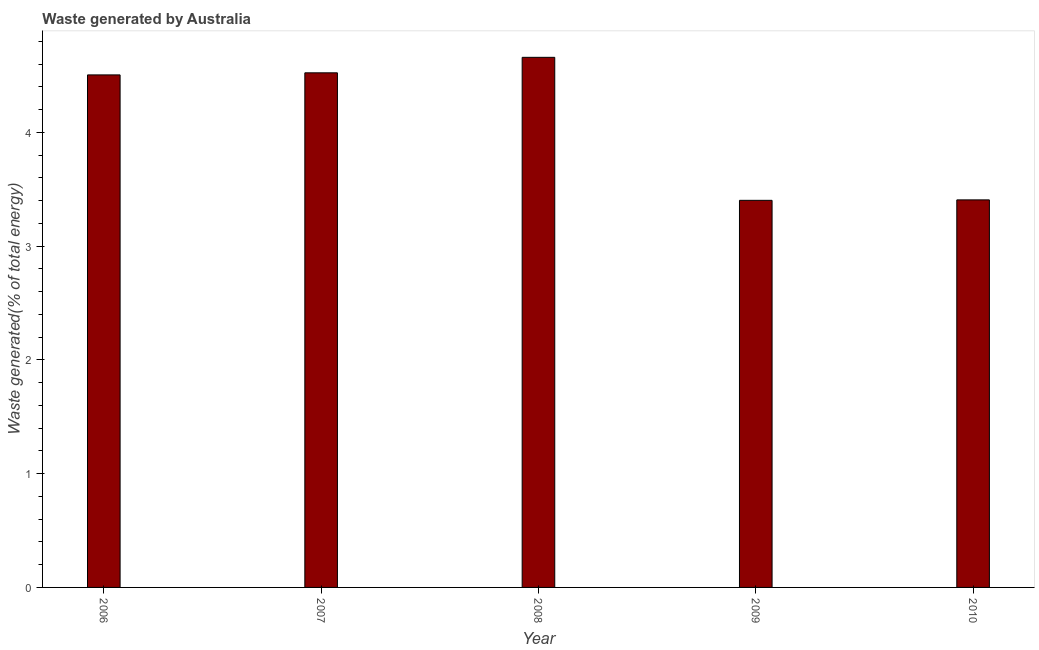Does the graph contain grids?
Give a very brief answer. No. What is the title of the graph?
Your response must be concise. Waste generated by Australia. What is the label or title of the X-axis?
Ensure brevity in your answer.  Year. What is the label or title of the Y-axis?
Keep it short and to the point. Waste generated(% of total energy). What is the amount of waste generated in 2008?
Give a very brief answer. 4.66. Across all years, what is the maximum amount of waste generated?
Ensure brevity in your answer.  4.66. Across all years, what is the minimum amount of waste generated?
Your response must be concise. 3.4. In which year was the amount of waste generated maximum?
Provide a succinct answer. 2008. In which year was the amount of waste generated minimum?
Provide a short and direct response. 2009. What is the sum of the amount of waste generated?
Your answer should be very brief. 20.5. What is the difference between the amount of waste generated in 2008 and 2010?
Your answer should be compact. 1.25. What is the average amount of waste generated per year?
Offer a very short reply. 4.1. What is the median amount of waste generated?
Ensure brevity in your answer.  4.51. Is the amount of waste generated in 2008 less than that in 2009?
Your answer should be compact. No. Is the difference between the amount of waste generated in 2006 and 2007 greater than the difference between any two years?
Keep it short and to the point. No. What is the difference between the highest and the second highest amount of waste generated?
Your answer should be very brief. 0.14. What is the difference between the highest and the lowest amount of waste generated?
Offer a very short reply. 1.26. In how many years, is the amount of waste generated greater than the average amount of waste generated taken over all years?
Your response must be concise. 3. Are all the bars in the graph horizontal?
Ensure brevity in your answer.  No. How many years are there in the graph?
Offer a terse response. 5. What is the difference between two consecutive major ticks on the Y-axis?
Provide a succinct answer. 1. Are the values on the major ticks of Y-axis written in scientific E-notation?
Offer a terse response. No. What is the Waste generated(% of total energy) in 2006?
Your answer should be very brief. 4.51. What is the Waste generated(% of total energy) of 2007?
Make the answer very short. 4.52. What is the Waste generated(% of total energy) in 2008?
Provide a short and direct response. 4.66. What is the Waste generated(% of total energy) in 2009?
Provide a succinct answer. 3.4. What is the Waste generated(% of total energy) in 2010?
Keep it short and to the point. 3.41. What is the difference between the Waste generated(% of total energy) in 2006 and 2007?
Ensure brevity in your answer.  -0.02. What is the difference between the Waste generated(% of total energy) in 2006 and 2008?
Ensure brevity in your answer.  -0.15. What is the difference between the Waste generated(% of total energy) in 2006 and 2009?
Ensure brevity in your answer.  1.1. What is the difference between the Waste generated(% of total energy) in 2006 and 2010?
Offer a very short reply. 1.1. What is the difference between the Waste generated(% of total energy) in 2007 and 2008?
Provide a short and direct response. -0.14. What is the difference between the Waste generated(% of total energy) in 2007 and 2009?
Provide a succinct answer. 1.12. What is the difference between the Waste generated(% of total energy) in 2007 and 2010?
Give a very brief answer. 1.12. What is the difference between the Waste generated(% of total energy) in 2008 and 2009?
Provide a short and direct response. 1.26. What is the difference between the Waste generated(% of total energy) in 2008 and 2010?
Make the answer very short. 1.25. What is the difference between the Waste generated(% of total energy) in 2009 and 2010?
Offer a terse response. -0. What is the ratio of the Waste generated(% of total energy) in 2006 to that in 2007?
Your response must be concise. 1. What is the ratio of the Waste generated(% of total energy) in 2006 to that in 2008?
Provide a succinct answer. 0.97. What is the ratio of the Waste generated(% of total energy) in 2006 to that in 2009?
Provide a succinct answer. 1.32. What is the ratio of the Waste generated(% of total energy) in 2006 to that in 2010?
Make the answer very short. 1.32. What is the ratio of the Waste generated(% of total energy) in 2007 to that in 2009?
Provide a succinct answer. 1.33. What is the ratio of the Waste generated(% of total energy) in 2007 to that in 2010?
Your answer should be compact. 1.33. What is the ratio of the Waste generated(% of total energy) in 2008 to that in 2009?
Offer a very short reply. 1.37. What is the ratio of the Waste generated(% of total energy) in 2008 to that in 2010?
Your response must be concise. 1.37. 